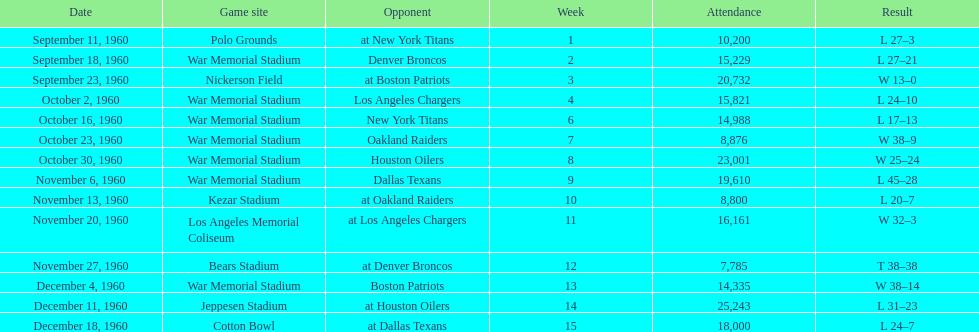What was the largest difference of points in a single game? 29. 